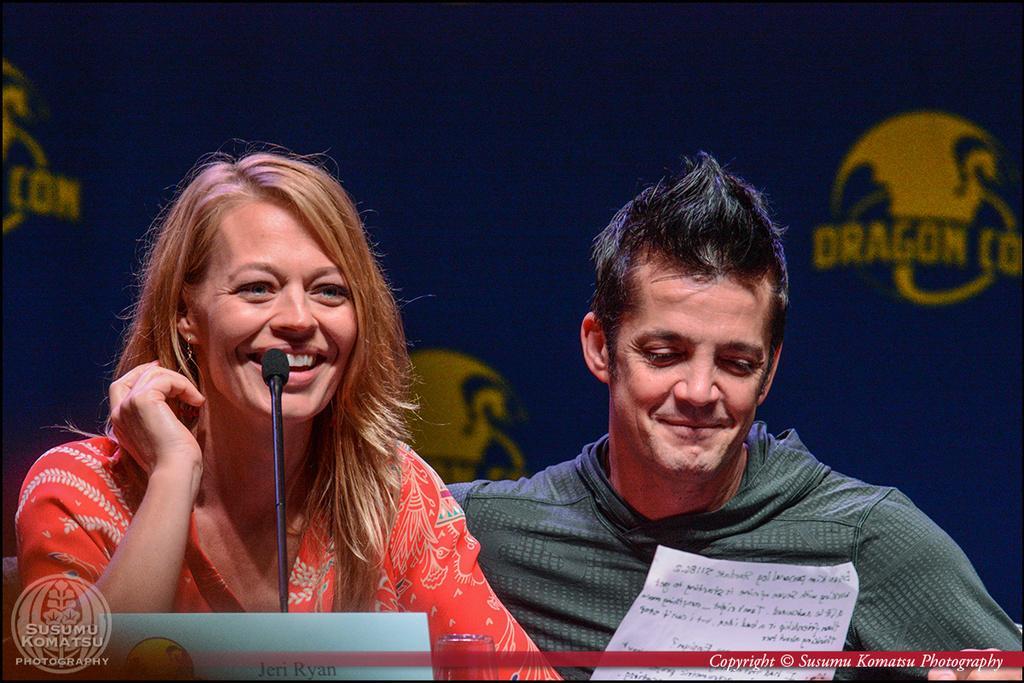Can you describe this image briefly? In the middle of the image we can see a microphone, glass and paper. Behind them two persons are sitting and smiling. At the top of the image we can see a banner. 